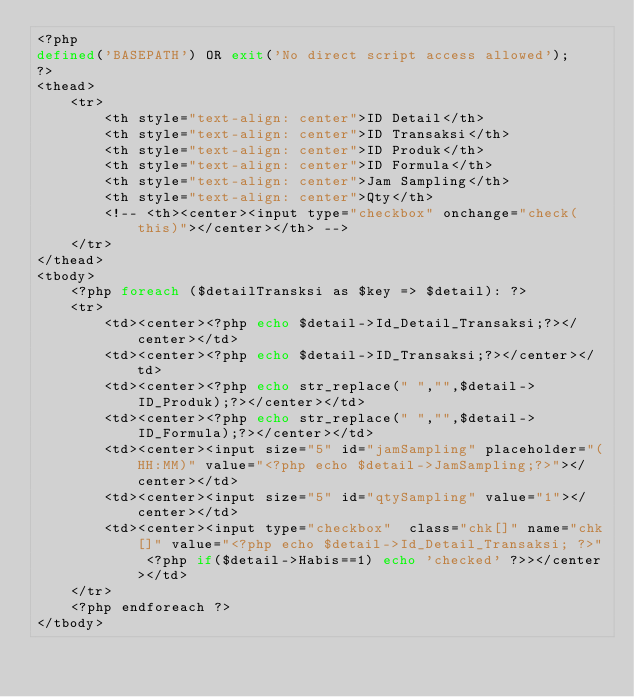<code> <loc_0><loc_0><loc_500><loc_500><_PHP_><?php
defined('BASEPATH') OR exit('No direct script access allowed');
?>
<thead>
    <tr>
        <th style="text-align: center">ID Detail</th>
        <th style="text-align: center">ID Transaksi</th>
        <th style="text-align: center">ID Produk</th>
        <th style="text-align: center">ID Formula</th>
        <th style="text-align: center">Jam Sampling</th>
        <th style="text-align: center">Qty</th>
        <!-- <th><center><input type="checkbox" onchange="check(this)"></center></th> -->
    </tr>
</thead>
<tbody>
    <?php foreach ($detailTransksi as $key => $detail): ?>
    <tr>
        <td><center><?php echo $detail->Id_Detail_Transaksi;?></center></td>
        <td><center><?php echo $detail->ID_Transaksi;?></center></td>
        <td><center><?php echo str_replace(" ","",$detail->ID_Produk);?></center></td>
        <td><center><?php echo str_replace(" ","",$detail->ID_Formula);?></center></td>
        <td><center><input size="5" id="jamSampling" placeholder="(HH:MM)" value="<?php echo $detail->JamSampling;?>"></center></td>
        <td><center><input size="5" id="qtySampling" value="1"></center></td>
        <td><center><input type="checkbox"  class="chk[]" name="chk[]" value="<?php echo $detail->Id_Detail_Transaksi; ?>" <?php if($detail->Habis==1) echo 'checked' ?>></center></td>
    </tr>
    <?php endforeach ?>
</tbody></code> 